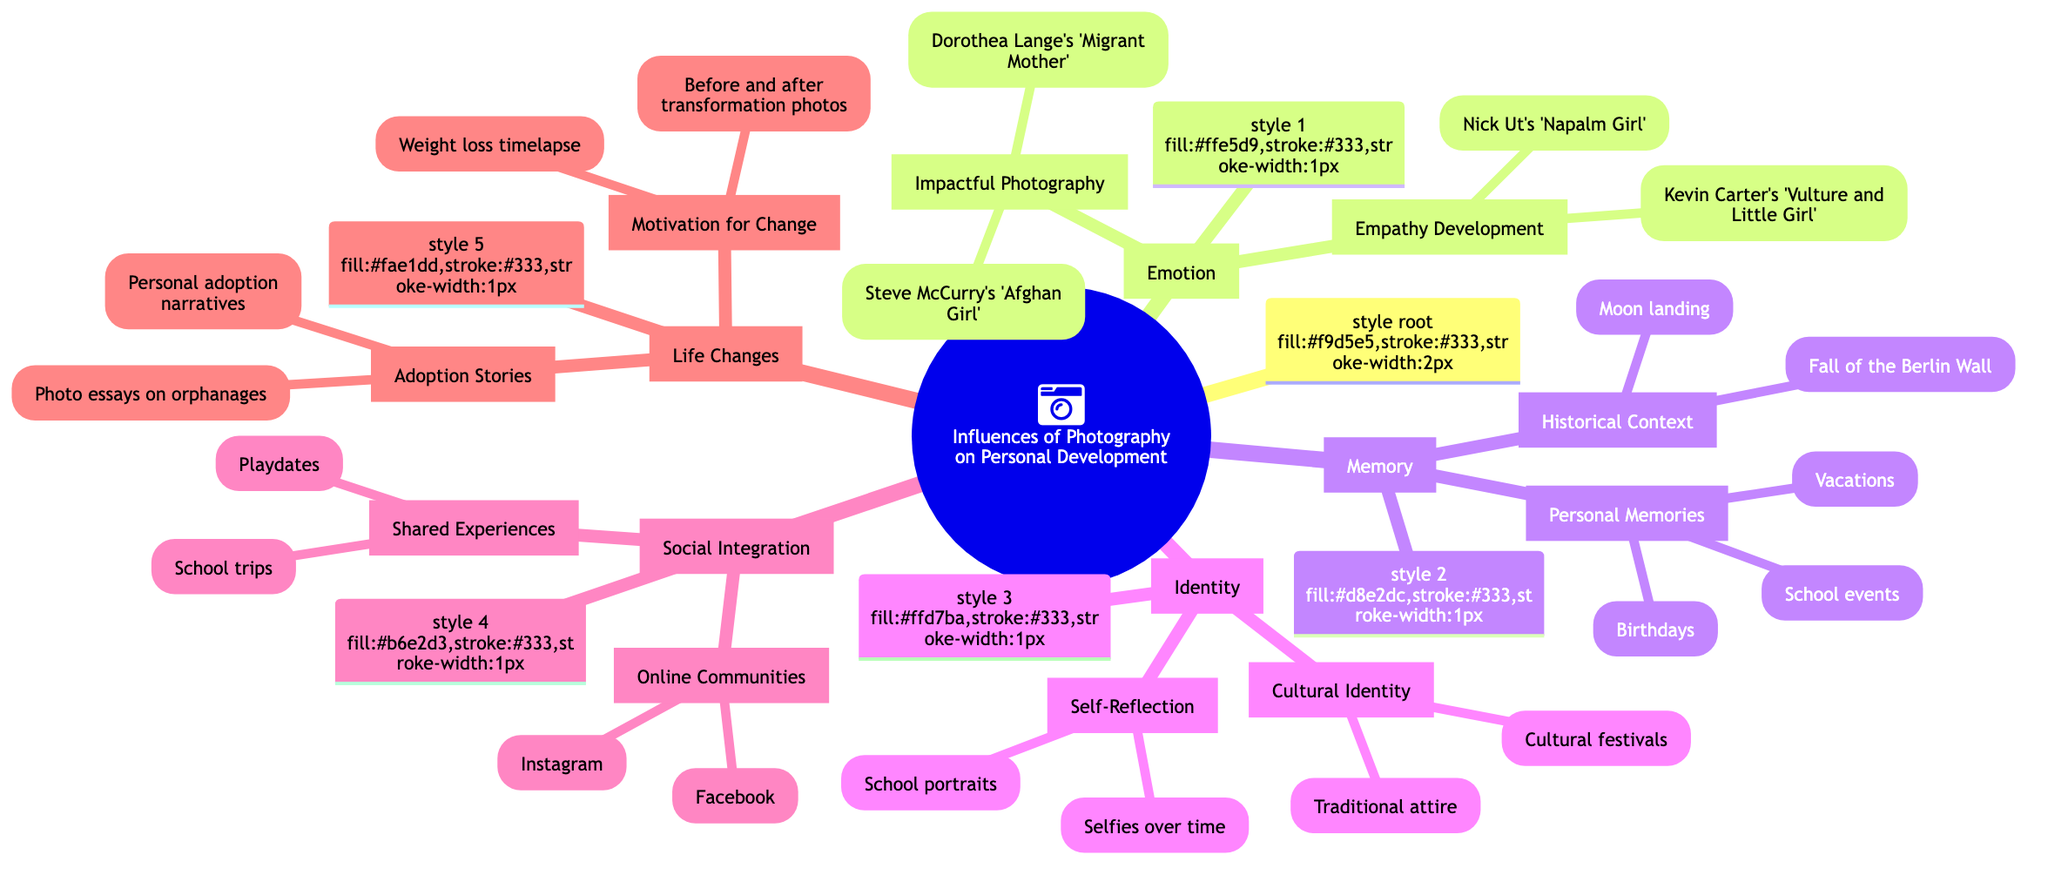What is the central topic of the diagram? The central topic is stated directly at the root of the diagram as "Influences of Photography on Personal Development."
Answer: Influences of Photography on Personal Development How many categories are there in the diagram? The diagram has five main categories listed under the central topic, which are Emotion, Memory, Identity, Social Integration, and Life Changes.
Answer: 5 Which example is associated with Empathy Development? To find the answer, we look under the Emotion category and then specifically under Empathy Development, which lists examples including "Kevin Carter's 'Vulture and Little Girl'."
Answer: Kevin Carter's 'Vulture and Little Girl' What are the two types of Life Changes presented? Under the Life Changes category, we see two subcategories: Adoption Stories and Motivation for Change.
Answer: Adoption Stories, Motivation for Change What is the relationship between Historical Context and its examples? Historical Context is a subcategory under Memory, and it has examples like "Moon landing" and "Fall of the Berlin Wall" that provide context for understanding past events.
Answer: Moon landing, Fall of the Berlin Wall How do Emotional photographs enhance empathy according to the diagram? The diagram states that emotional photographs can show different perspectives, which enhances empathy. Therefore, the link between emotional photographs and empathy is established through the ability to showcase various viewpoints.
Answer: Through different perspectives Which category includes personal narratives related to adoption? The category that includes personal narratives related to adoption is Life Changes, specifically under Adoption Stories.
Answer: Life Changes What type of photo essays influence Adoption? The diagram specifically mentions that "Photo essays on orphanages" can influence adoption, as listed under Adoption Stories in the Life Changes category.
Answer: Photo essays on orphanages How does sharing photos on social platforms benefit social connections? According to the diagram, sharing photos on social platforms like Instagram and Facebook strengthens social connections by fostering interactions among users.
Answer: Strengthens social connections 